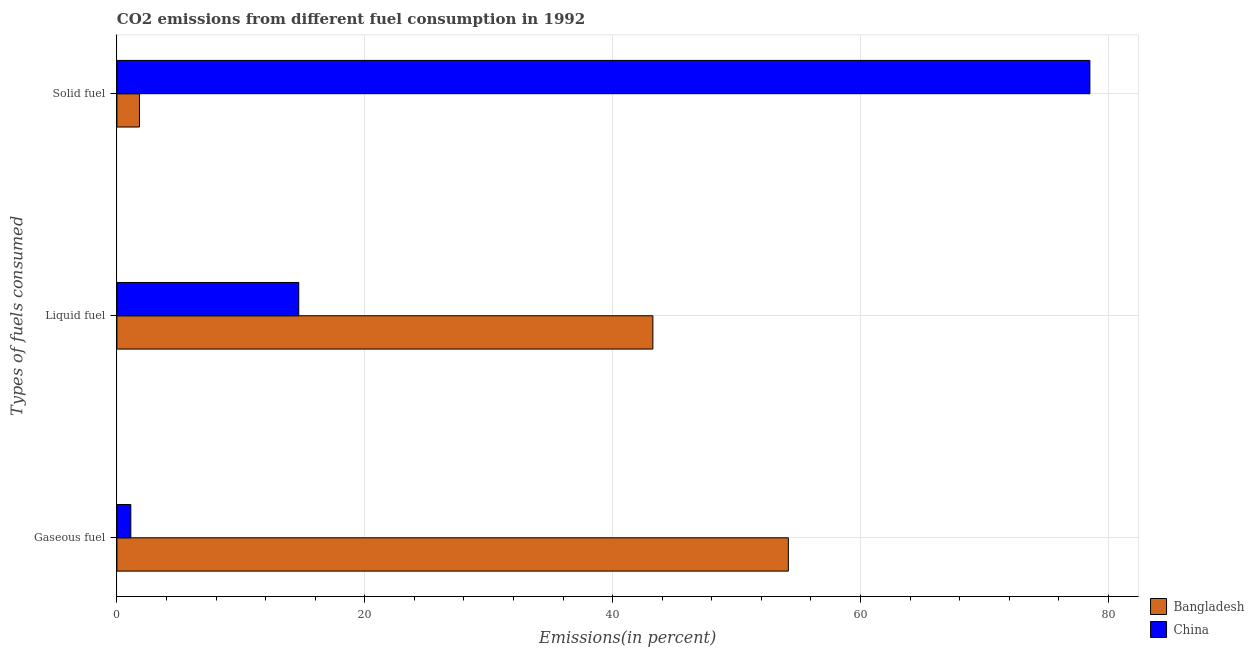How many bars are there on the 2nd tick from the top?
Offer a terse response. 2. How many bars are there on the 1st tick from the bottom?
Your answer should be very brief. 2. What is the label of the 1st group of bars from the top?
Provide a succinct answer. Solid fuel. What is the percentage of solid fuel emission in China?
Give a very brief answer. 78.5. Across all countries, what is the maximum percentage of solid fuel emission?
Offer a terse response. 78.5. Across all countries, what is the minimum percentage of liquid fuel emission?
Your answer should be very brief. 14.67. In which country was the percentage of liquid fuel emission minimum?
Your answer should be very brief. China. What is the total percentage of solid fuel emission in the graph?
Ensure brevity in your answer.  80.32. What is the difference between the percentage of solid fuel emission in China and that in Bangladesh?
Your response must be concise. 76.69. What is the difference between the percentage of solid fuel emission in Bangladesh and the percentage of liquid fuel emission in China?
Provide a succinct answer. -12.85. What is the average percentage of gaseous fuel emission per country?
Give a very brief answer. 27.65. What is the difference between the percentage of liquid fuel emission and percentage of gaseous fuel emission in China?
Make the answer very short. 13.55. In how many countries, is the percentage of gaseous fuel emission greater than 68 %?
Keep it short and to the point. 0. What is the ratio of the percentage of solid fuel emission in Bangladesh to that in China?
Provide a short and direct response. 0.02. What is the difference between the highest and the second highest percentage of liquid fuel emission?
Offer a terse response. 28.57. What is the difference between the highest and the lowest percentage of solid fuel emission?
Make the answer very short. 76.69. In how many countries, is the percentage of solid fuel emission greater than the average percentage of solid fuel emission taken over all countries?
Make the answer very short. 1. Is it the case that in every country, the sum of the percentage of gaseous fuel emission and percentage of liquid fuel emission is greater than the percentage of solid fuel emission?
Ensure brevity in your answer.  No. Are all the bars in the graph horizontal?
Ensure brevity in your answer.  Yes. How many countries are there in the graph?
Ensure brevity in your answer.  2. Are the values on the major ticks of X-axis written in scientific E-notation?
Your answer should be very brief. No. How many legend labels are there?
Make the answer very short. 2. How are the legend labels stacked?
Keep it short and to the point. Vertical. What is the title of the graph?
Your answer should be compact. CO2 emissions from different fuel consumption in 1992. What is the label or title of the X-axis?
Ensure brevity in your answer.  Emissions(in percent). What is the label or title of the Y-axis?
Make the answer very short. Types of fuels consumed. What is the Emissions(in percent) of Bangladesh in Gaseous fuel?
Your answer should be very brief. 54.17. What is the Emissions(in percent) of China in Gaseous fuel?
Your response must be concise. 1.12. What is the Emissions(in percent) of Bangladesh in Liquid fuel?
Keep it short and to the point. 43.24. What is the Emissions(in percent) in China in Liquid fuel?
Your answer should be compact. 14.67. What is the Emissions(in percent) of Bangladesh in Solid fuel?
Offer a terse response. 1.82. What is the Emissions(in percent) of China in Solid fuel?
Make the answer very short. 78.5. Across all Types of fuels consumed, what is the maximum Emissions(in percent) in Bangladesh?
Provide a short and direct response. 54.17. Across all Types of fuels consumed, what is the maximum Emissions(in percent) in China?
Your response must be concise. 78.5. Across all Types of fuels consumed, what is the minimum Emissions(in percent) of Bangladesh?
Keep it short and to the point. 1.82. Across all Types of fuels consumed, what is the minimum Emissions(in percent) in China?
Offer a terse response. 1.12. What is the total Emissions(in percent) of Bangladesh in the graph?
Provide a succinct answer. 99.24. What is the total Emissions(in percent) in China in the graph?
Your answer should be very brief. 94.3. What is the difference between the Emissions(in percent) of Bangladesh in Gaseous fuel and that in Liquid fuel?
Ensure brevity in your answer.  10.93. What is the difference between the Emissions(in percent) of China in Gaseous fuel and that in Liquid fuel?
Give a very brief answer. -13.55. What is the difference between the Emissions(in percent) of Bangladesh in Gaseous fuel and that in Solid fuel?
Give a very brief answer. 52.36. What is the difference between the Emissions(in percent) in China in Gaseous fuel and that in Solid fuel?
Provide a succinct answer. -77.38. What is the difference between the Emissions(in percent) of Bangladesh in Liquid fuel and that in Solid fuel?
Make the answer very short. 41.43. What is the difference between the Emissions(in percent) in China in Liquid fuel and that in Solid fuel?
Make the answer very short. -63.83. What is the difference between the Emissions(in percent) of Bangladesh in Gaseous fuel and the Emissions(in percent) of China in Liquid fuel?
Make the answer very short. 39.5. What is the difference between the Emissions(in percent) in Bangladesh in Gaseous fuel and the Emissions(in percent) in China in Solid fuel?
Make the answer very short. -24.33. What is the difference between the Emissions(in percent) in Bangladesh in Liquid fuel and the Emissions(in percent) in China in Solid fuel?
Give a very brief answer. -35.26. What is the average Emissions(in percent) in Bangladesh per Types of fuels consumed?
Provide a short and direct response. 33.08. What is the average Emissions(in percent) of China per Types of fuels consumed?
Make the answer very short. 31.43. What is the difference between the Emissions(in percent) in Bangladesh and Emissions(in percent) in China in Gaseous fuel?
Ensure brevity in your answer.  53.05. What is the difference between the Emissions(in percent) of Bangladesh and Emissions(in percent) of China in Liquid fuel?
Keep it short and to the point. 28.57. What is the difference between the Emissions(in percent) in Bangladesh and Emissions(in percent) in China in Solid fuel?
Offer a very short reply. -76.69. What is the ratio of the Emissions(in percent) of Bangladesh in Gaseous fuel to that in Liquid fuel?
Keep it short and to the point. 1.25. What is the ratio of the Emissions(in percent) in China in Gaseous fuel to that in Liquid fuel?
Provide a short and direct response. 0.08. What is the ratio of the Emissions(in percent) of Bangladesh in Gaseous fuel to that in Solid fuel?
Your answer should be very brief. 29.8. What is the ratio of the Emissions(in percent) of China in Gaseous fuel to that in Solid fuel?
Keep it short and to the point. 0.01. What is the ratio of the Emissions(in percent) in Bangladesh in Liquid fuel to that in Solid fuel?
Provide a succinct answer. 23.78. What is the ratio of the Emissions(in percent) of China in Liquid fuel to that in Solid fuel?
Ensure brevity in your answer.  0.19. What is the difference between the highest and the second highest Emissions(in percent) in Bangladesh?
Offer a very short reply. 10.93. What is the difference between the highest and the second highest Emissions(in percent) of China?
Ensure brevity in your answer.  63.83. What is the difference between the highest and the lowest Emissions(in percent) in Bangladesh?
Ensure brevity in your answer.  52.36. What is the difference between the highest and the lowest Emissions(in percent) in China?
Provide a succinct answer. 77.38. 